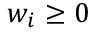Convert formula to latex. <formula><loc_0><loc_0><loc_500><loc_500>w _ { i } \geq 0</formula> 